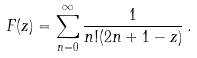Convert formula to latex. <formula><loc_0><loc_0><loc_500><loc_500>F ( z ) = \sum _ { n = 0 } ^ { \infty } \frac { 1 } { n ! ( 2 n + 1 - z ) } \, .</formula> 